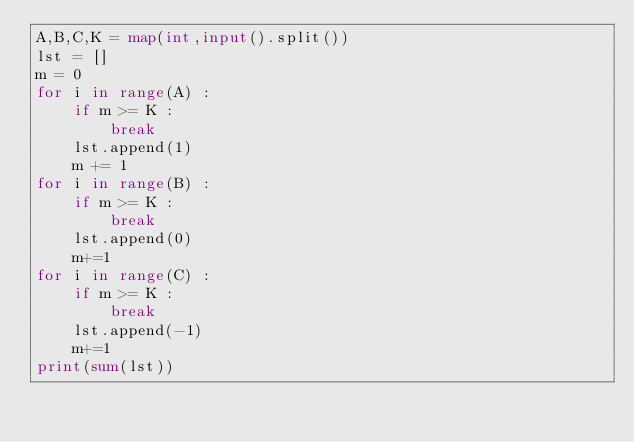<code> <loc_0><loc_0><loc_500><loc_500><_Python_>A,B,C,K = map(int,input().split())
lst = []
m = 0
for i in range(A) :
    if m >= K :
        break
    lst.append(1)
    m += 1
for i in range(B) :
    if m >= K :
        break
    lst.append(0)
    m+=1
for i in range(C) :
    if m >= K :
        break
    lst.append(-1)
    m+=1
print(sum(lst))</code> 